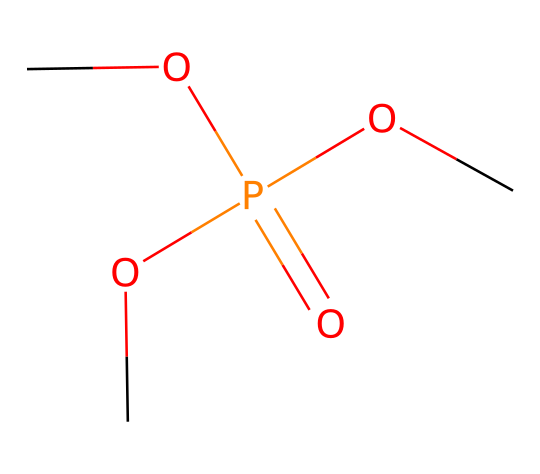What is the main functional group present in this compound? The compound has a phosphate group as indicated by the presence of phosphorus bonded to four oxygen atoms, with one being double bonded. The phosphate group is essential in various applications, including fire retardancy.
Answer: phosphate How many carbon atoms are in this chemical structure? By examining the structure generated from the SMILES representation, there are three carbon atoms connected to the three methoxy groups (–OCH3), indicated by the methyl groups.
Answer: three What type of chemical reaction could this compound participate in? The presence of the phosphate group suggests that this compound can undergo esterification reactions since it contains multiple methoxy (alkoxy) groups. These reactions often occur in the synthesis and modification of fire-retardant materials.
Answer: esterification How many total oxygen atoms are shown in this chemical? In the chemical structure, there are four oxygen atoms: one in the phosphate group and three in the methoxy groups (–OCH3).
Answer: four What is the oxidation state of phosphorus in this compound? Phosphorus typically has an oxidation state of +5 in organophosphates, as seen when it forms bonds with four oxygen atoms; this confirms it is in the higher oxidation state characteristic of phosphoric compounds used for fire retardancy.
Answer: plus five 